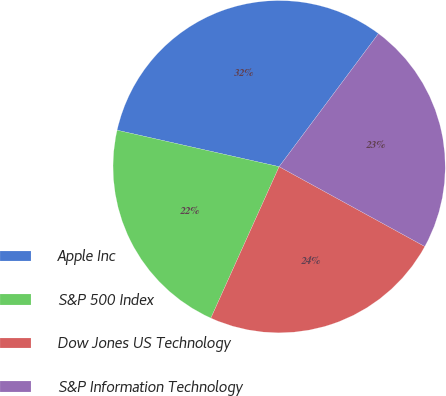Convert chart to OTSL. <chart><loc_0><loc_0><loc_500><loc_500><pie_chart><fcel>Apple Inc<fcel>S&P 500 Index<fcel>Dow Jones US Technology<fcel>S&P Information Technology<nl><fcel>31.68%<fcel>21.78%<fcel>23.76%<fcel>22.77%<nl></chart> 